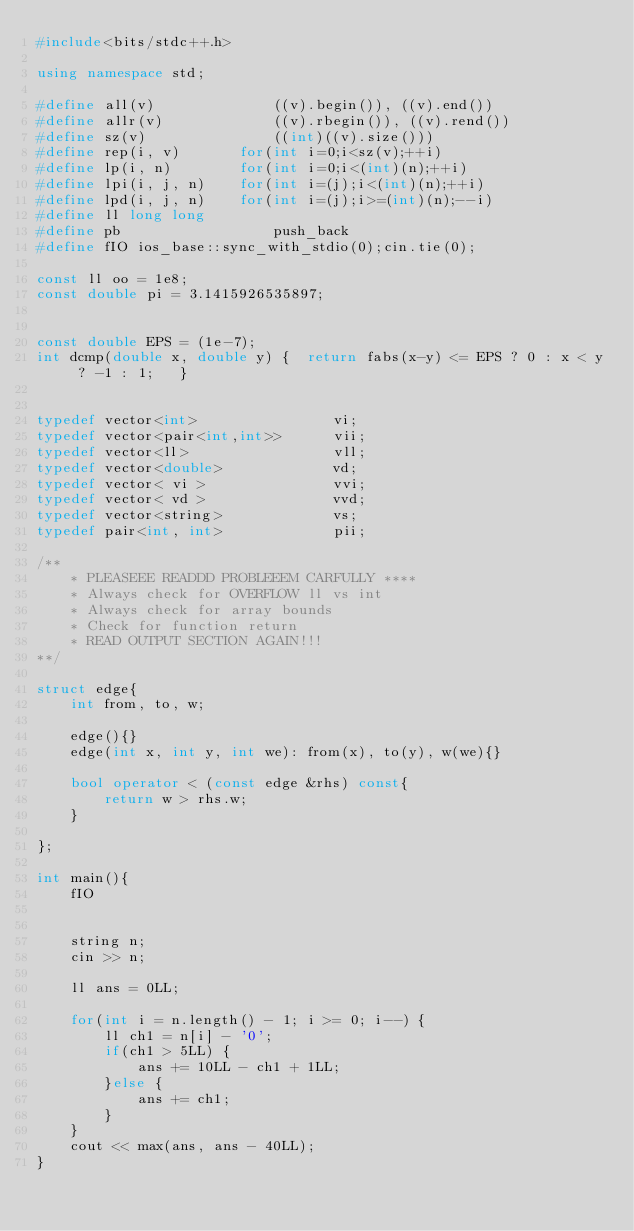<code> <loc_0><loc_0><loc_500><loc_500><_C++_>#include<bits/stdc++.h>

using namespace std;

#define all(v)				((v).begin()), ((v).end())
#define allr(v)				((v).rbegin()), ((v).rend())
#define sz(v)				((int)((v).size()))
#define rep(i, v)		for(int i=0;i<sz(v);++i)
#define lp(i, n)		for(int i=0;i<(int)(n);++i)
#define lpi(i, j, n)	for(int i=(j);i<(int)(n);++i)
#define lpd(i, j, n)	for(int i=(j);i>=(int)(n);--i)
#define ll long long
#define pb					push_back
#define fIO ios_base::sync_with_stdio(0);cin.tie(0);

const ll oo = 1e8;
const double pi = 3.1415926535897;


const double EPS = (1e-7);
int dcmp(double x, double y) {	return fabs(x-y) <= EPS ? 0 : x < y ? -1 : 1;	}


typedef vector<int>                vi;
typedef vector<pair<int,int>>      vii;
typedef vector<ll>                 vll;
typedef vector<double>             vd;
typedef vector< vi >               vvi;
typedef vector< vd >               vvd;
typedef vector<string>             vs;
typedef pair<int, int>             pii;

/**
    * PLEASEEE READDD PROBLEEEM CARFULLY ****
    * Always check for OVERFLOW ll vs int
    * Always check for array bounds
    * Check for function return
    * READ OUTPUT SECTION AGAIN!!!
**/

struct edge{
    int from, to, w;

    edge(){}
    edge(int x, int y, int we): from(x), to(y), w(we){}

    bool operator < (const edge &rhs) const{
        return w > rhs.w;
    }

};

int main(){
    fIO


    string n;
    cin >> n;

    ll ans = 0LL;

    for(int i = n.length() - 1; i >= 0; i--) {
        ll ch1 = n[i] - '0';
        if(ch1 > 5LL) {
            ans += 10LL - ch1 + 1LL;
        }else {
            ans += ch1;
        }
    }
    cout << max(ans, ans - 40LL);
}






</code> 